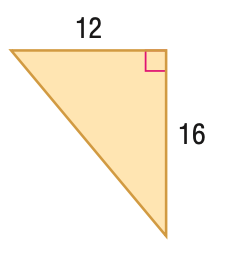Question: Find the perimeter of the figure.
Choices:
A. 28
B. 48
C. 96
D. 192
Answer with the letter. Answer: B 